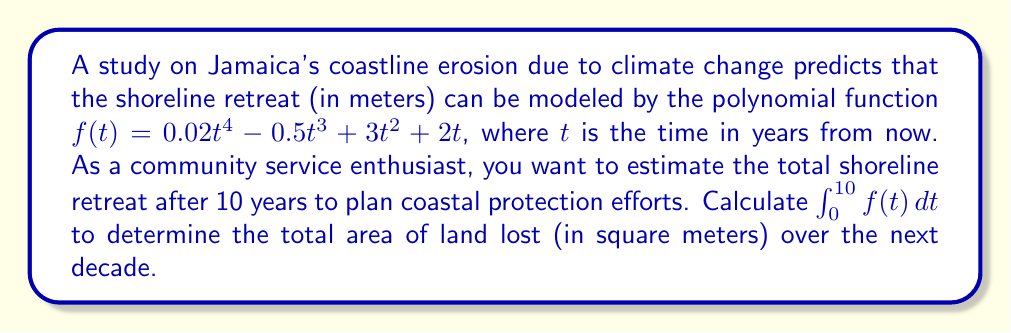Solve this math problem. To solve this problem, we need to integrate the given function $f(t)$ from 0 to 10:

1) First, let's integrate the function:
   $$\int_0^{10} f(t) dt = \int_0^{10} (0.02t^4 - 0.5t^3 + 3t^2 + 2t) dt$$

2) Integrate each term:
   $$\left[\frac{0.02t^5}{5} - \frac{0.5t^4}{4} + t^3 + t^2\right]_0^{10}$$

3) Evaluate at the upper and lower bounds:
   Upper bound (t = 10):
   $$\frac{0.02(10^5)}{5} - \frac{0.5(10^4)}{4} + 10^3 + 10^2$$
   $$= 400 - 1250 + 1000 + 100 = 250$$

   Lower bound (t = 0):
   $$\frac{0.02(0^5)}{5} - \frac{0.5(0^4)}{4} + 0^3 + 0^2 = 0$$

4) Subtract the lower bound from the upper bound:
   $$250 - 0 = 250$$

Therefore, the total area of land lost over the next decade is 250 square meters.
Answer: 250 square meters 